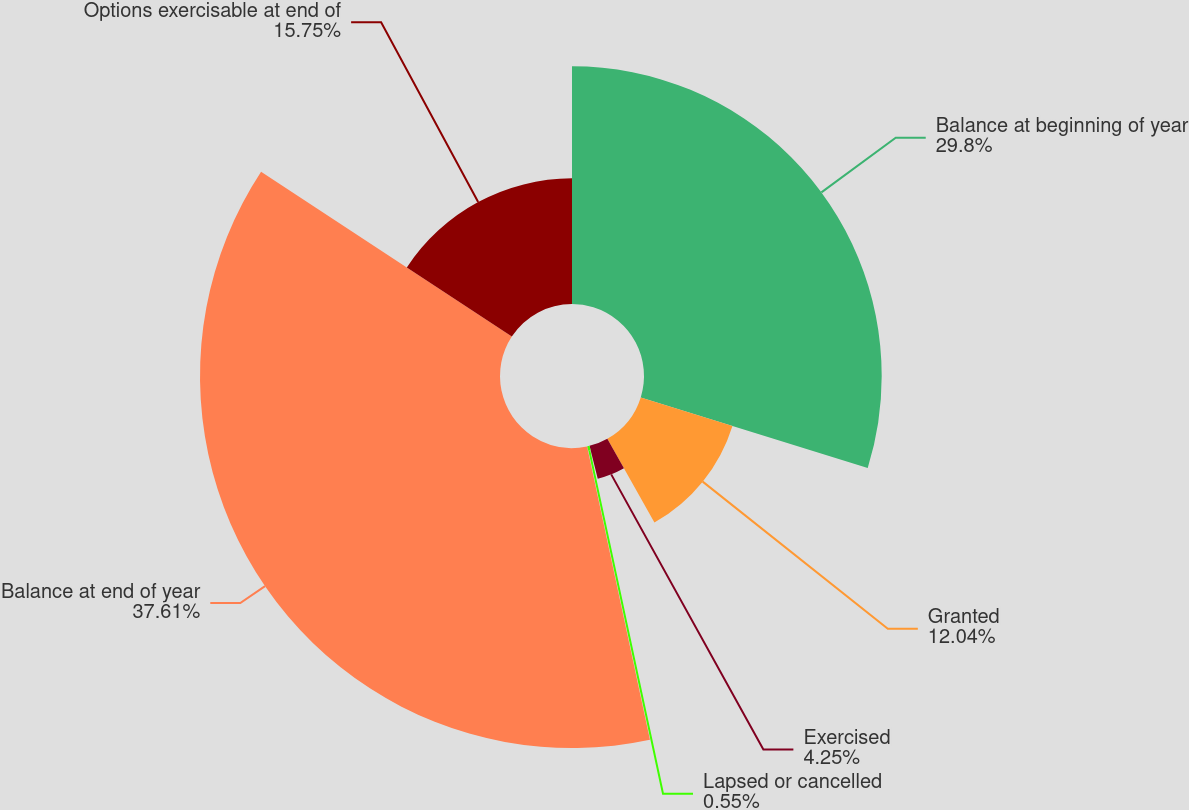Convert chart to OTSL. <chart><loc_0><loc_0><loc_500><loc_500><pie_chart><fcel>Balance at beginning of year<fcel>Granted<fcel>Exercised<fcel>Lapsed or cancelled<fcel>Balance at end of year<fcel>Options exercisable at end of<nl><fcel>29.8%<fcel>12.04%<fcel>4.25%<fcel>0.55%<fcel>37.61%<fcel>15.75%<nl></chart> 